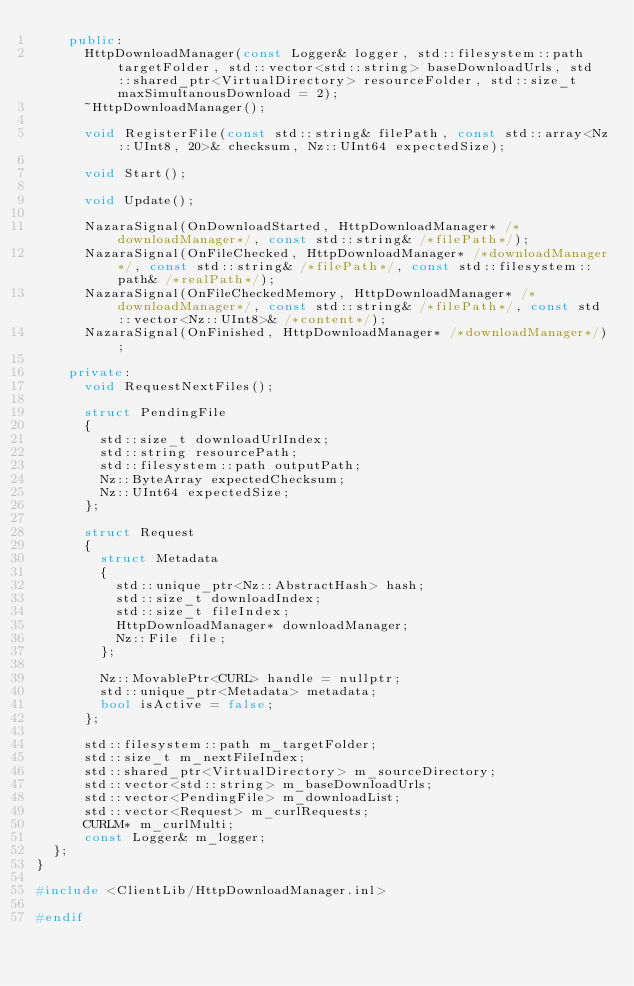<code> <loc_0><loc_0><loc_500><loc_500><_C++_>		public:
			HttpDownloadManager(const Logger& logger, std::filesystem::path targetFolder, std::vector<std::string> baseDownloadUrls, std::shared_ptr<VirtualDirectory> resourceFolder, std::size_t maxSimultanousDownload = 2);
			~HttpDownloadManager();

			void RegisterFile(const std::string& filePath, const std::array<Nz::UInt8, 20>& checksum, Nz::UInt64 expectedSize);

			void Start();

			void Update();

			NazaraSignal(OnDownloadStarted, HttpDownloadManager* /*downloadManager*/, const std::string& /*filePath*/);
			NazaraSignal(OnFileChecked, HttpDownloadManager* /*downloadManager*/, const std::string& /*filePath*/, const std::filesystem::path& /*realPath*/);
			NazaraSignal(OnFileCheckedMemory, HttpDownloadManager* /*downloadManager*/, const std::string& /*filePath*/, const std::vector<Nz::UInt8>& /*content*/);
			NazaraSignal(OnFinished, HttpDownloadManager* /*downloadManager*/);

		private:
			void RequestNextFiles();

			struct PendingFile
			{
				std::size_t downloadUrlIndex;
				std::string resourcePath;
				std::filesystem::path outputPath;
				Nz::ByteArray expectedChecksum;
				Nz::UInt64 expectedSize;
			};

			struct Request
			{
				struct Metadata
				{
					std::unique_ptr<Nz::AbstractHash> hash;
					std::size_t downloadIndex;
					std::size_t fileIndex;
					HttpDownloadManager* downloadManager;
					Nz::File file;
				};

				Nz::MovablePtr<CURL> handle = nullptr;
				std::unique_ptr<Metadata> metadata;
				bool isActive = false;
			};

			std::filesystem::path m_targetFolder;
			std::size_t m_nextFileIndex;
			std::shared_ptr<VirtualDirectory> m_sourceDirectory;
			std::vector<std::string> m_baseDownloadUrls;
			std::vector<PendingFile> m_downloadList;
			std::vector<Request> m_curlRequests;
			CURLM* m_curlMulti;
			const Logger& m_logger;
	};
}

#include <ClientLib/HttpDownloadManager.inl>

#endif
</code> 